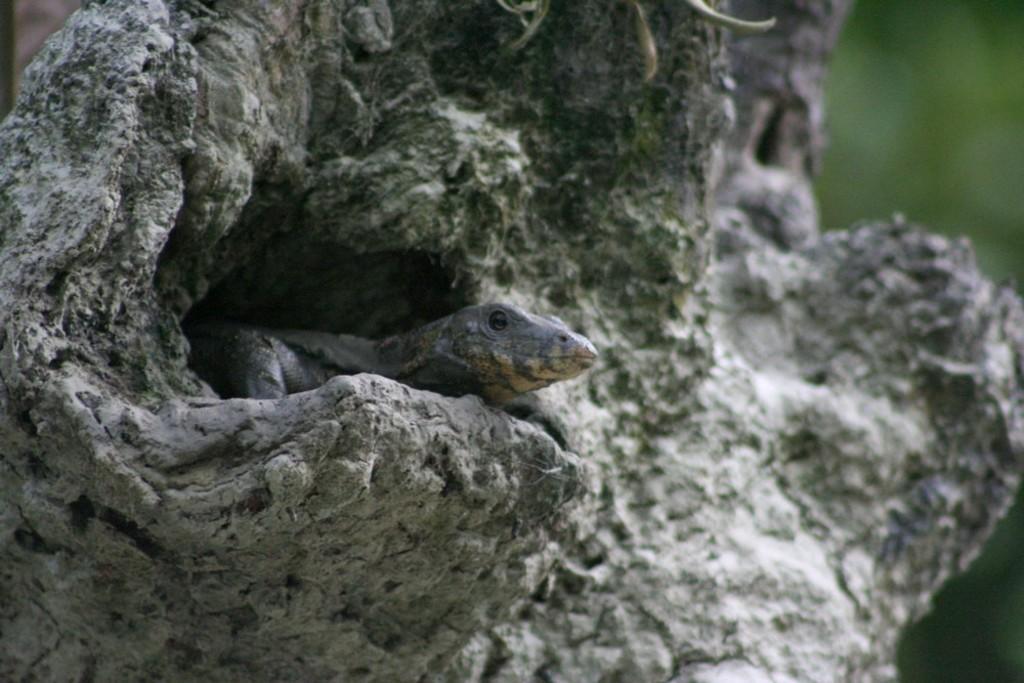Can you describe this image briefly? In this picture we can see a lizard inside a wooden hole. 